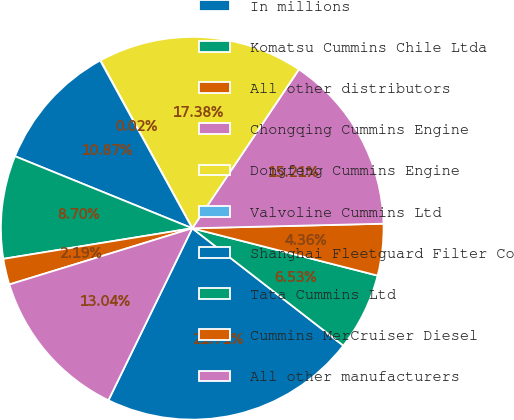Convert chart. <chart><loc_0><loc_0><loc_500><loc_500><pie_chart><fcel>In millions<fcel>Komatsu Cummins Chile Ltda<fcel>All other distributors<fcel>Chongqing Cummins Engine<fcel>Dongfeng Cummins Engine<fcel>Valvoline Cummins Ltd<fcel>Shanghai Fleetguard Filter Co<fcel>Tata Cummins Ltd<fcel>Cummins MerCruiser Diesel<fcel>All other manufacturers<nl><fcel>21.71%<fcel>6.53%<fcel>4.36%<fcel>15.21%<fcel>17.38%<fcel>0.02%<fcel>10.87%<fcel>8.7%<fcel>2.19%<fcel>13.04%<nl></chart> 